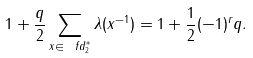Convert formula to latex. <formula><loc_0><loc_0><loc_500><loc_500>1 + \frac { q } { 2 } \sum _ { x \in \ f d _ { 2 } ^ { * } } \lambda ( x ^ { - 1 } ) = 1 + \frac { 1 } { 2 } ( - 1 ) ^ { r } q .</formula> 